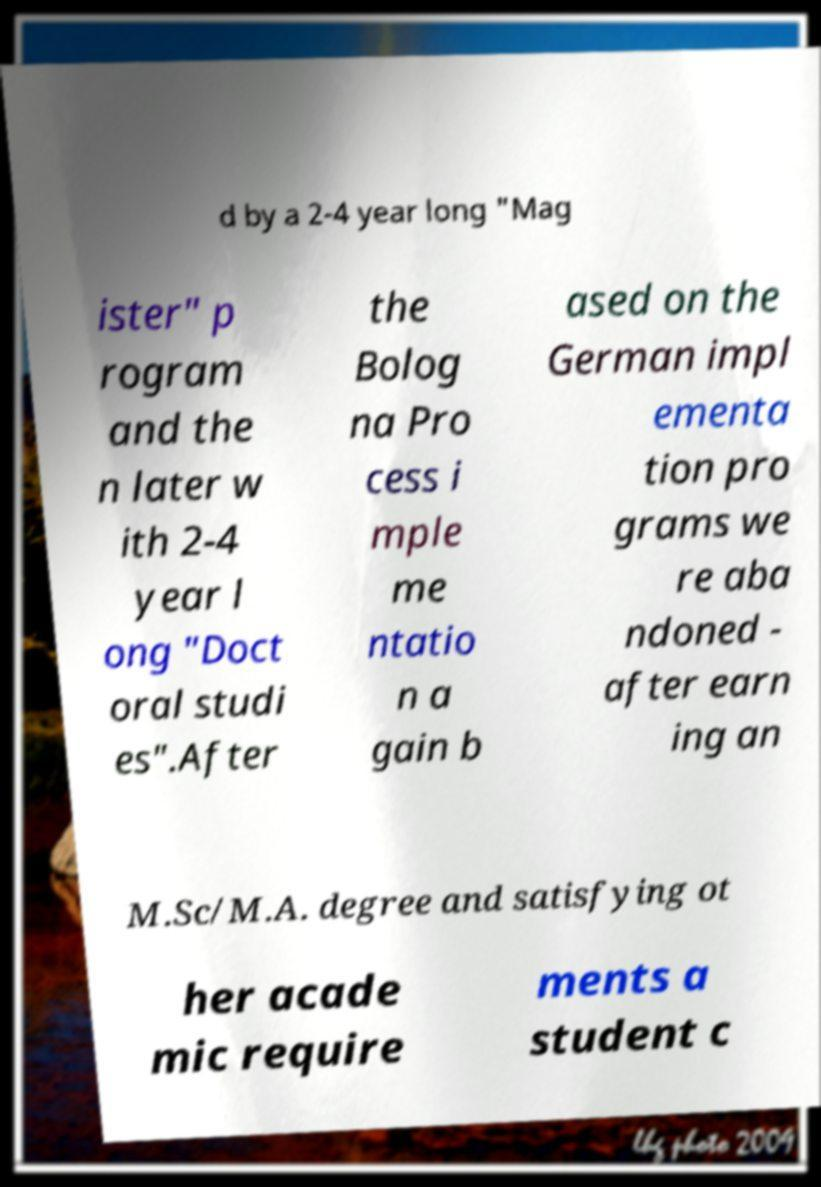There's text embedded in this image that I need extracted. Can you transcribe it verbatim? d by a 2-4 year long "Mag ister" p rogram and the n later w ith 2-4 year l ong "Doct oral studi es".After the Bolog na Pro cess i mple me ntatio n a gain b ased on the German impl ementa tion pro grams we re aba ndoned - after earn ing an M.Sc/M.A. degree and satisfying ot her acade mic require ments a student c 